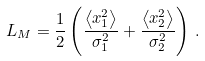<formula> <loc_0><loc_0><loc_500><loc_500>L _ { M } = \frac { 1 } { 2 } \left ( \frac { \left < x _ { 1 } ^ { 2 } \right > } { \sigma ^ { 2 } _ { 1 } } + \frac { \left < x _ { 2 } ^ { 2 } \right > } { \sigma ^ { 2 } _ { 2 } } \right ) \, .</formula> 